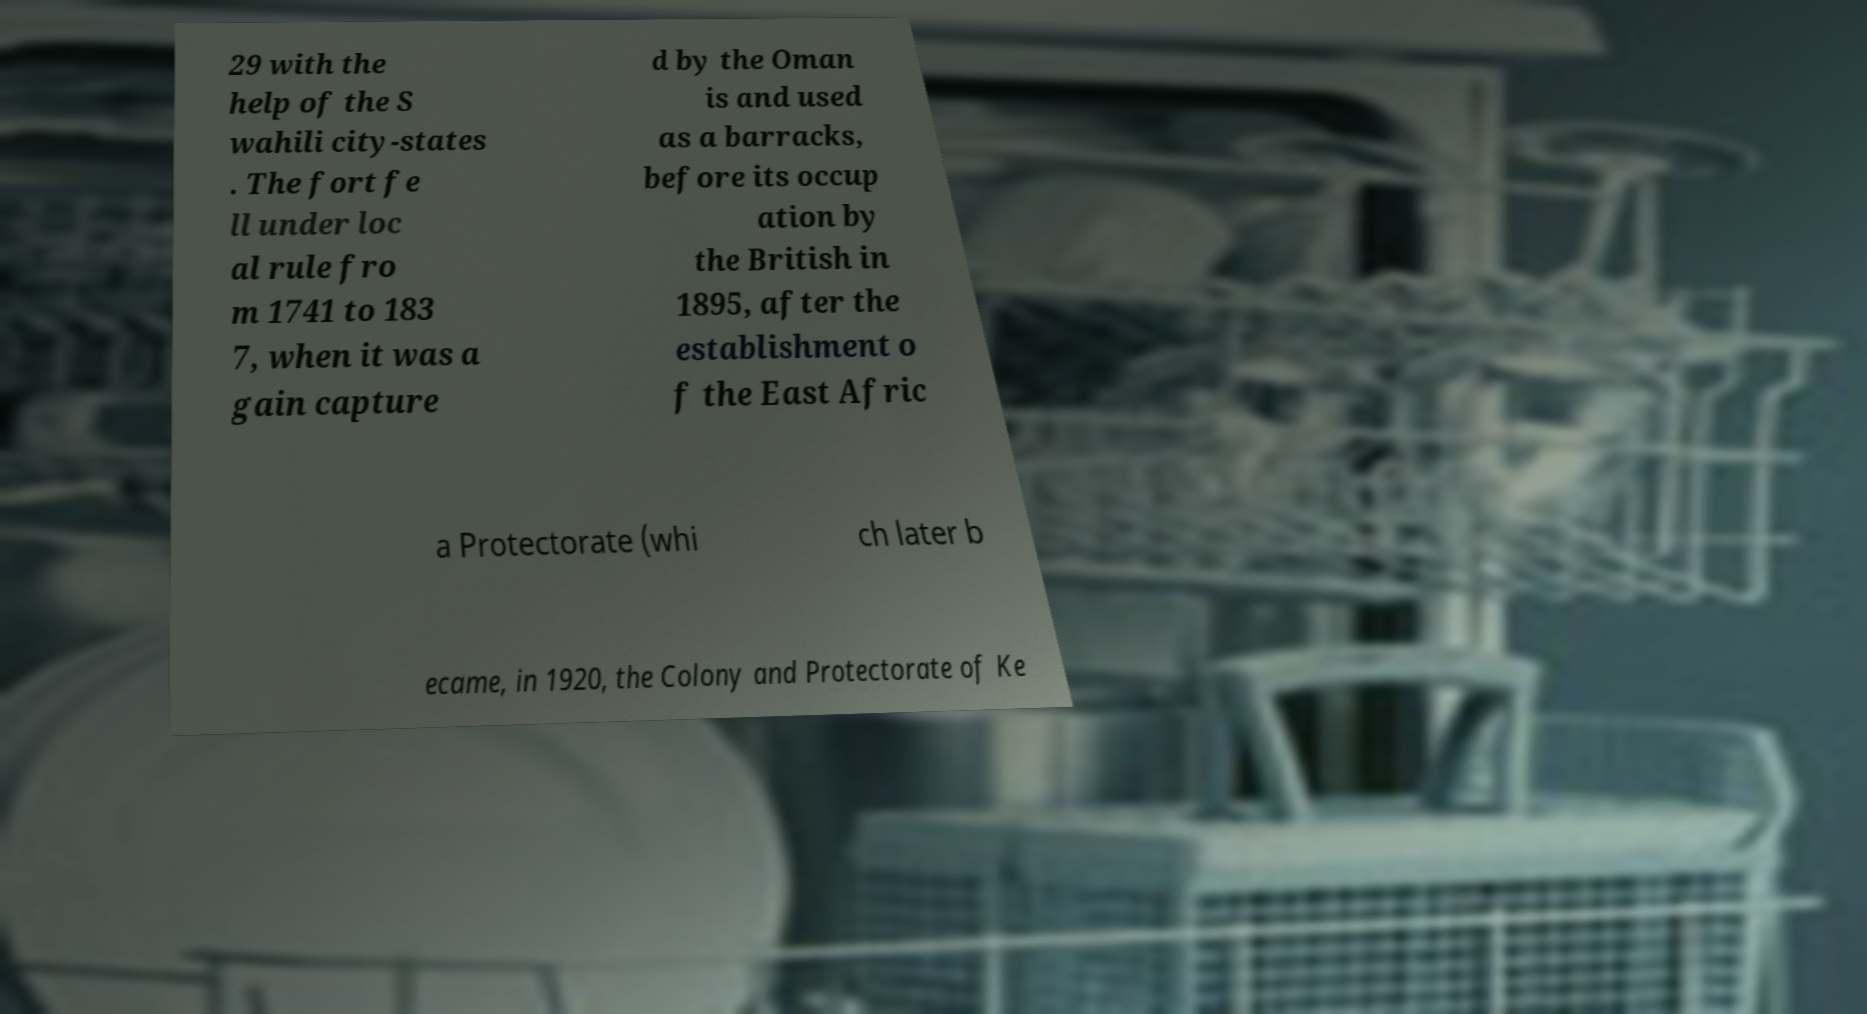Can you accurately transcribe the text from the provided image for me? 29 with the help of the S wahili city-states . The fort fe ll under loc al rule fro m 1741 to 183 7, when it was a gain capture d by the Oman is and used as a barracks, before its occup ation by the British in 1895, after the establishment o f the East Afric a Protectorate (whi ch later b ecame, in 1920, the Colony and Protectorate of Ke 